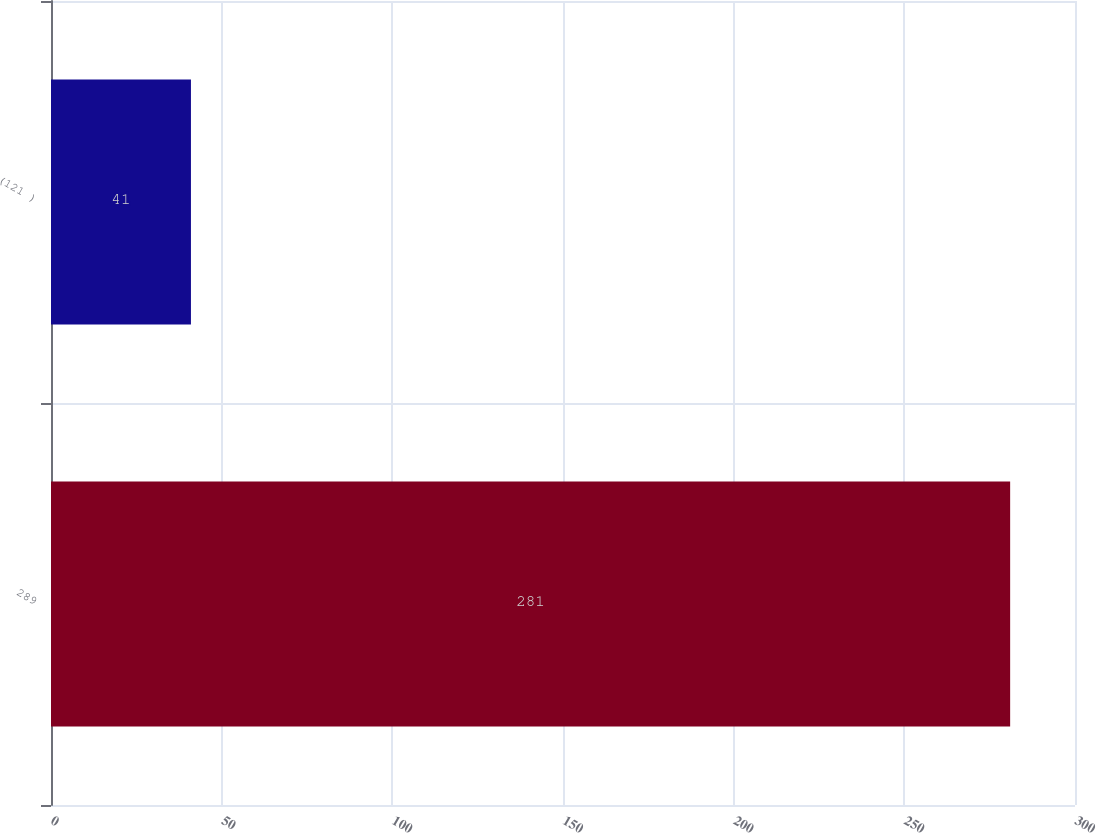<chart> <loc_0><loc_0><loc_500><loc_500><bar_chart><fcel>289<fcel>(121 )<nl><fcel>281<fcel>41<nl></chart> 